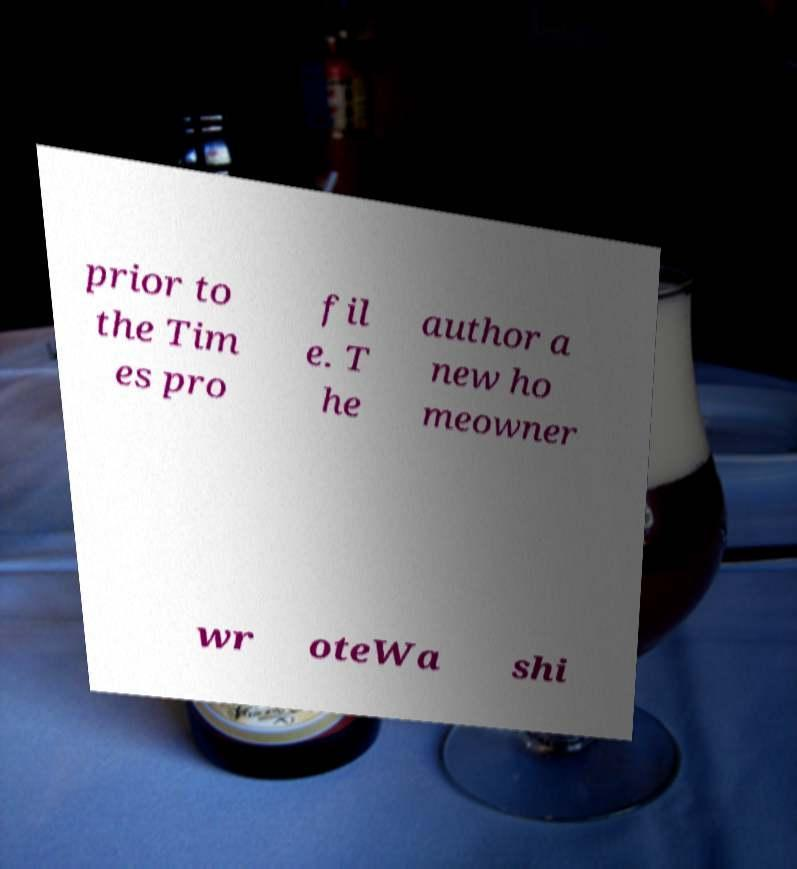For documentation purposes, I need the text within this image transcribed. Could you provide that? prior to the Tim es pro fil e. T he author a new ho meowner wr oteWa shi 